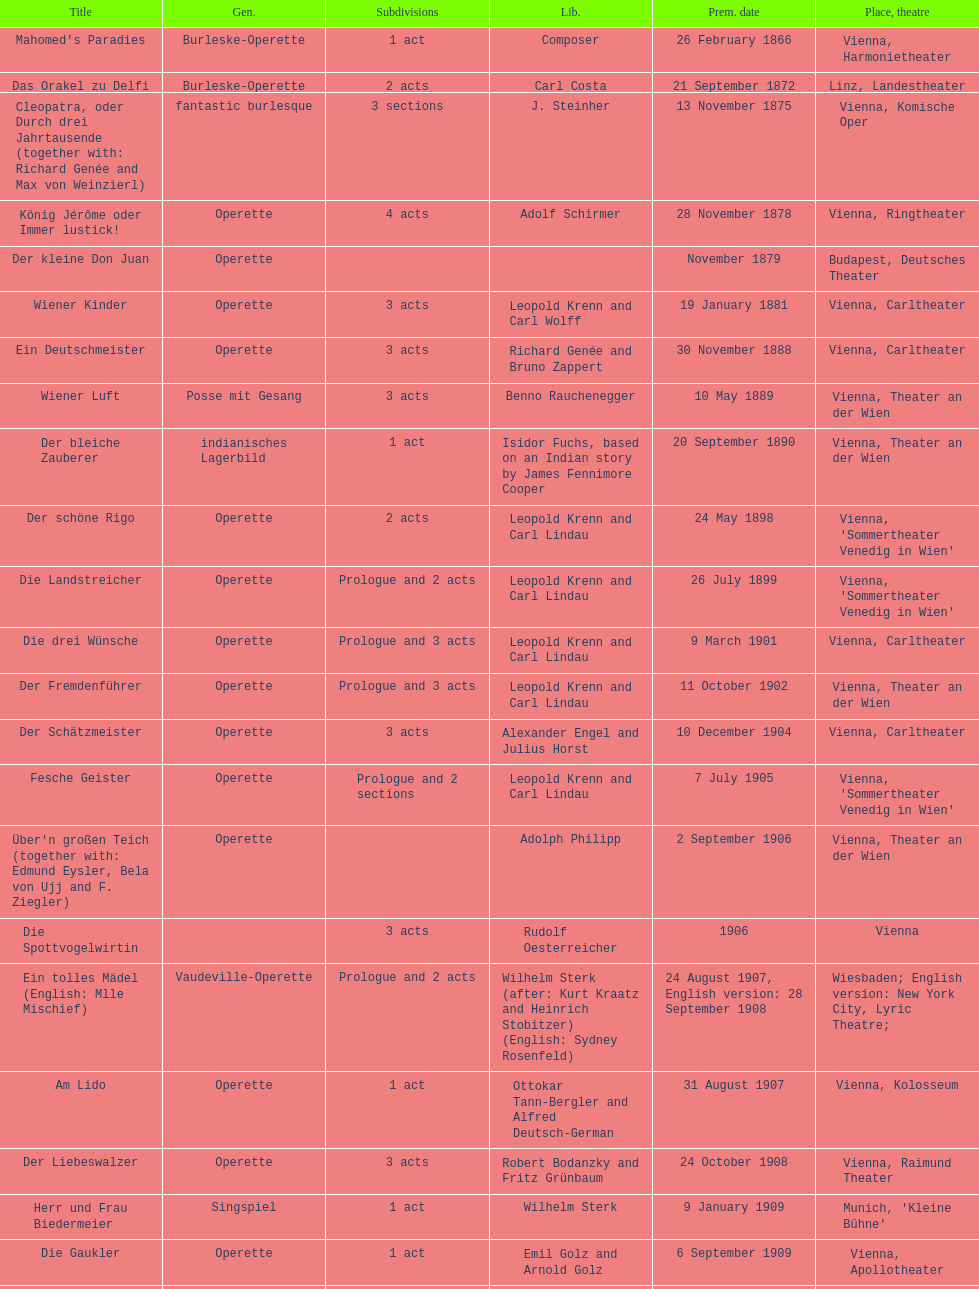How many number of 1 acts were there? 5. Could you parse the entire table as a dict? {'header': ['Title', 'Gen.', 'Sub\xaddivisions', 'Lib.', 'Prem. date', 'Place, theatre'], 'rows': [["Mahomed's Paradies", 'Burleske-Operette', '1 act', 'Composer', '26 February 1866', 'Vienna, Harmonietheater'], ['Das Orakel zu Delfi', 'Burleske-Operette', '2 acts', 'Carl Costa', '21 September 1872', 'Linz, Landestheater'], ['Cleopatra, oder Durch drei Jahrtausende (together with: Richard Genée and Max von Weinzierl)', 'fantastic burlesque', '3 sections', 'J. Steinher', '13 November 1875', 'Vienna, Komische Oper'], ['König Jérôme oder Immer lustick!', 'Operette', '4 acts', 'Adolf Schirmer', '28 November 1878', 'Vienna, Ringtheater'], ['Der kleine Don Juan', 'Operette', '', '', 'November 1879', 'Budapest, Deutsches Theater'], ['Wiener Kinder', 'Operette', '3 acts', 'Leopold Krenn and Carl Wolff', '19 January 1881', 'Vienna, Carltheater'], ['Ein Deutschmeister', 'Operette', '3 acts', 'Richard Genée and Bruno Zappert', '30 November 1888', 'Vienna, Carltheater'], ['Wiener Luft', 'Posse mit Gesang', '3 acts', 'Benno Rauchenegger', '10 May 1889', 'Vienna, Theater an der Wien'], ['Der bleiche Zauberer', 'indianisches Lagerbild', '1 act', 'Isidor Fuchs, based on an Indian story by James Fennimore Cooper', '20 September 1890', 'Vienna, Theater an der Wien'], ['Der schöne Rigo', 'Operette', '2 acts', 'Leopold Krenn and Carl Lindau', '24 May 1898', "Vienna, 'Sommertheater Venedig in Wien'"], ['Die Landstreicher', 'Operette', 'Prologue and 2 acts', 'Leopold Krenn and Carl Lindau', '26 July 1899', "Vienna, 'Sommertheater Venedig in Wien'"], ['Die drei Wünsche', 'Operette', 'Prologue and 3 acts', 'Leopold Krenn and Carl Lindau', '9 March 1901', 'Vienna, Carltheater'], ['Der Fremdenführer', 'Operette', 'Prologue and 3 acts', 'Leopold Krenn and Carl Lindau', '11 October 1902', 'Vienna, Theater an der Wien'], ['Der Schätzmeister', 'Operette', '3 acts', 'Alexander Engel and Julius Horst', '10 December 1904', 'Vienna, Carltheater'], ['Fesche Geister', 'Operette', 'Prologue and 2 sections', 'Leopold Krenn and Carl Lindau', '7 July 1905', "Vienna, 'Sommertheater Venedig in Wien'"], ["Über'n großen Teich (together with: Edmund Eysler, Bela von Ujj and F. Ziegler)", 'Operette', '', 'Adolph Philipp', '2 September 1906', 'Vienna, Theater an der Wien'], ['Die Spottvogelwirtin', '', '3 acts', 'Rudolf Oesterreicher', '1906', 'Vienna'], ['Ein tolles Mädel (English: Mlle Mischief)', 'Vaudeville-Operette', 'Prologue and 2 acts', 'Wilhelm Sterk (after: Kurt Kraatz and Heinrich Stobitzer) (English: Sydney Rosenfeld)', '24 August 1907, English version: 28 September 1908', 'Wiesbaden; English version: New York City, Lyric Theatre;'], ['Am Lido', 'Operette', '1 act', 'Ottokar Tann-Bergler and Alfred Deutsch-German', '31 August 1907', 'Vienna, Kolosseum'], ['Der Liebeswalzer', 'Operette', '3 acts', 'Robert Bodanzky and Fritz Grünbaum', '24 October 1908', 'Vienna, Raimund Theater'], ['Herr und Frau Biedermeier', 'Singspiel', '1 act', 'Wilhelm Sterk', '9 January 1909', "Munich, 'Kleine Bühne'"], ['Die Gaukler', 'Operette', '1 act', 'Emil Golz and Arnold Golz', '6 September 1909', 'Vienna, Apollotheater'], ['Ball bei Hof', 'Operette', '3 acts', 'Wilhelm Sterk (after the comedy "Hofgunst" by Thilo von Trotha)', '22 January 1911', 'Stettin, Stadttheater'], ['In fünfzig Jahren — "Zukunftstraum einer Küchenfee"', 'Burleske-Operette', '2 acts', 'Leopold Krenn and Carl Lindau', '13 January 1911', 'Vienna, Ronacher'], ['Manöverkinder', 'Operette', '2 acts', 'Oskar Friedmann and Fritz Lunzer', '22 June 1912', "Vienna, Sommerbühne 'Kaisergarten'"], ['Der Husarengeneral (new version of Manöverkinder)', 'Operette', '3 acts', 'Oskar Friedmann and Fritz Lunzer', '3 October 1913', 'Vienna, Raimund Theater'], ['Fürst Casimir', 'Operette', '3 acts', 'Max Neal and Max Ferner', '13 September 1913', 'Vienna, Carltheater'], ['Das dumme Herz', 'Operette', '3 acts', 'Rudolf Oesterreicher and Wilhelm Sterk', '27 February 1914', 'Vienna, Johann Strauss-Theater'], ['Der Kriegsberichterstatter (together with: Edmund Eysler, Bruno Granichstaedten, Oskar Nedbal, Charles Weinberger)', 'Operette', '8 scenes', 'Rudolf Oesterreicher and Wilhelm Sterk', '(1914)', ''], ['Im siebenten Himmel', 'Operette', '3 acts', 'Max Neal and Max Ferner', '26 February 1916', 'Munich, Theater am Gärtnerplatz'], ['Deutschmeisterkapelle', 'Operette', '', 'Hubert Marischka and Rudolf Oesterreicher', '30 May 1958', 'Vienna, Raimund Theater'], ['Die verliebte Eskadron', 'Operette', '3 acts', 'Wilhelm Sterk (after B. Buchbinder)', '11 July 1930', 'Vienna, Johann-Strauß-Theater']]} 